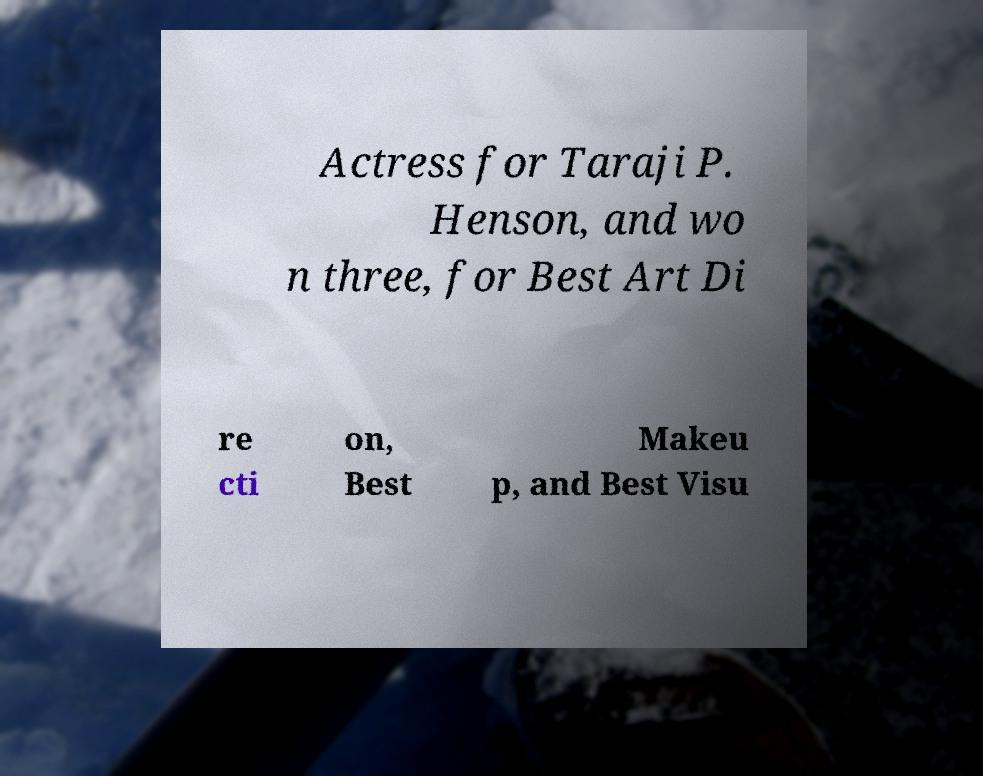Please identify and transcribe the text found in this image. Actress for Taraji P. Henson, and wo n three, for Best Art Di re cti on, Best Makeu p, and Best Visu 